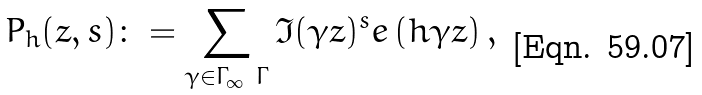<formula> <loc_0><loc_0><loc_500><loc_500>P _ { h } ( z , s ) \colon = \sum _ { \gamma \in \Gamma _ { \infty } \ \Gamma } \Im ( \gamma z ) ^ { s } e \left ( h \gamma z \right ) ,</formula> 